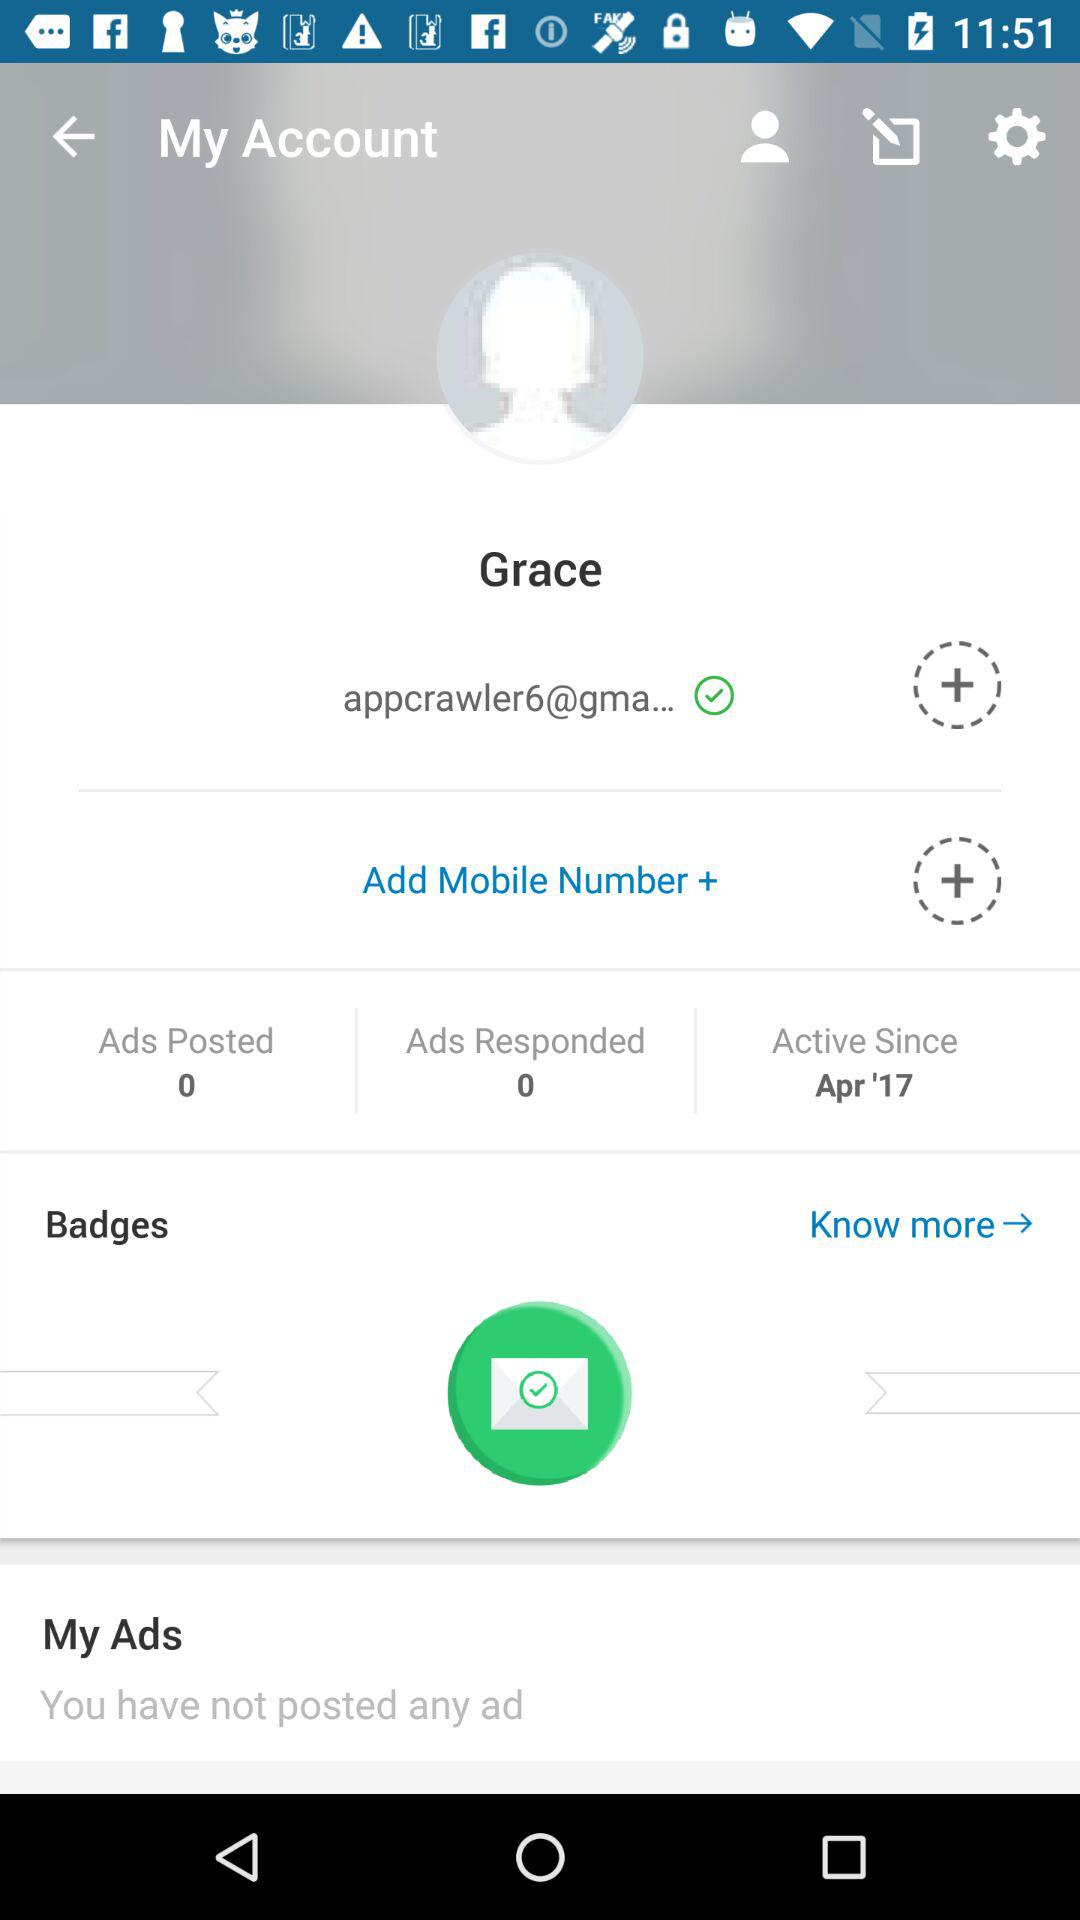Since when is the account active? The account has been active since April 2017. 